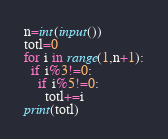Convert code to text. <code><loc_0><loc_0><loc_500><loc_500><_Python_>n=int(input())
totl=0
for i in range(1,n+1):
  if i%3!=0:
    if i%5!=0:
      totl+=i
print(totl)</code> 